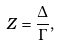Convert formula to latex. <formula><loc_0><loc_0><loc_500><loc_500>Z = \frac { \Delta } { \Gamma } ,</formula> 